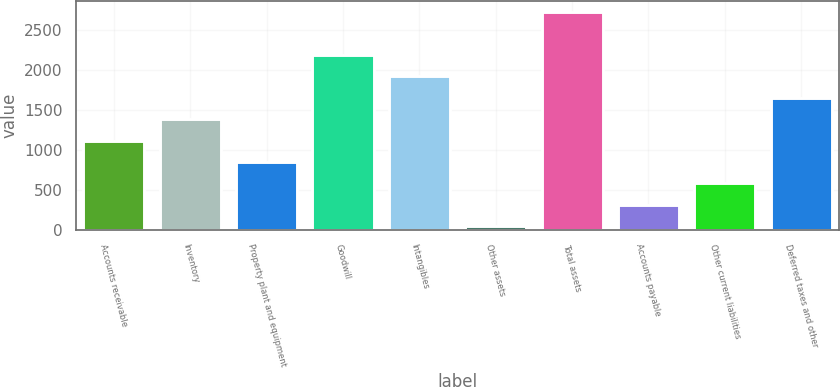<chart> <loc_0><loc_0><loc_500><loc_500><bar_chart><fcel>Accounts receivable<fcel>Inventory<fcel>Property plant and equipment<fcel>Goodwill<fcel>Intangibles<fcel>Other assets<fcel>Total assets<fcel>Accounts payable<fcel>Other current liabilities<fcel>Deferred taxes and other<nl><fcel>1116.6<fcel>1384.5<fcel>848.7<fcel>2188.2<fcel>1920.3<fcel>45<fcel>2724<fcel>312.9<fcel>580.8<fcel>1652.4<nl></chart> 